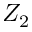<formula> <loc_0><loc_0><loc_500><loc_500>Z _ { 2 }</formula> 